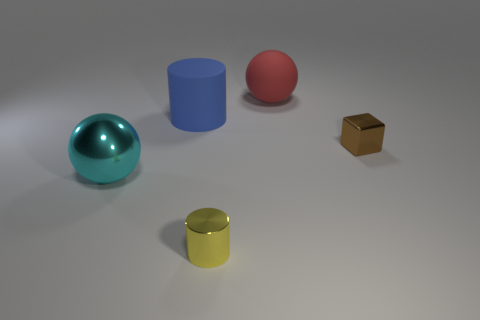Subtract all cyan balls. How many balls are left? 1 Subtract 1 cylinders. How many cylinders are left? 1 Add 2 large gray balls. How many objects exist? 7 Subtract all cylinders. How many objects are left? 3 Subtract all green cylinders. How many green balls are left? 0 Subtract all blue blocks. Subtract all tiny yellow cylinders. How many objects are left? 4 Add 1 matte cylinders. How many matte cylinders are left? 2 Add 1 gray balls. How many gray balls exist? 1 Subtract 0 brown cylinders. How many objects are left? 5 Subtract all green cubes. Subtract all gray cylinders. How many cubes are left? 1 